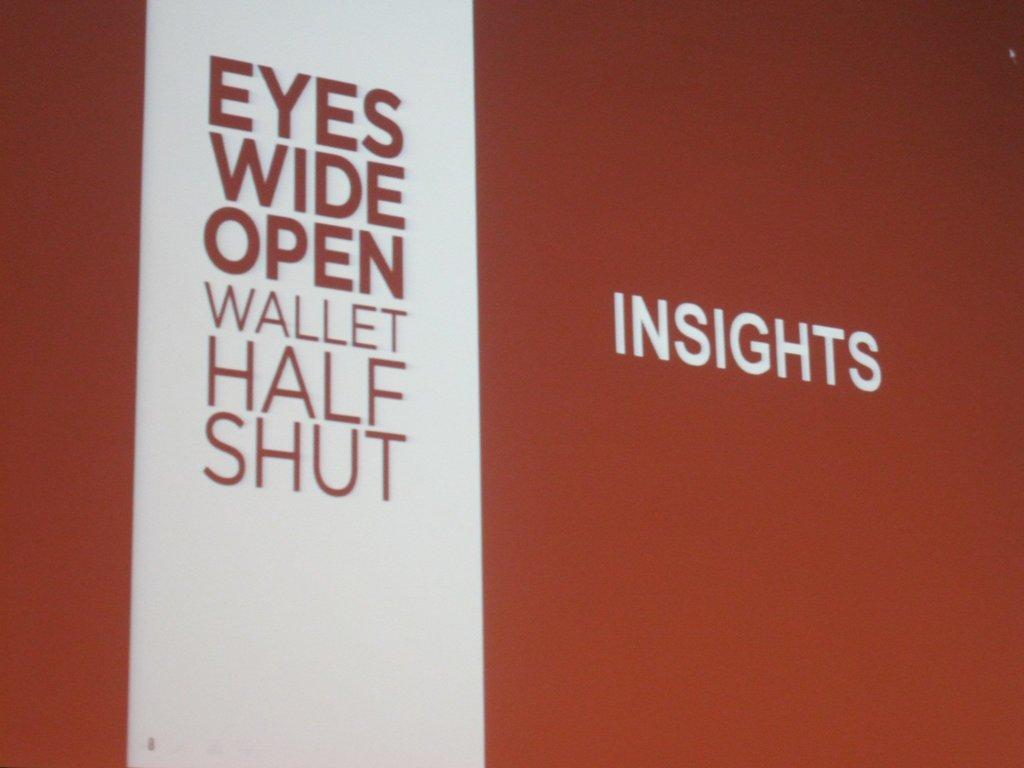Please provide a concise description of this image. Here we can see texts written on a platform. 